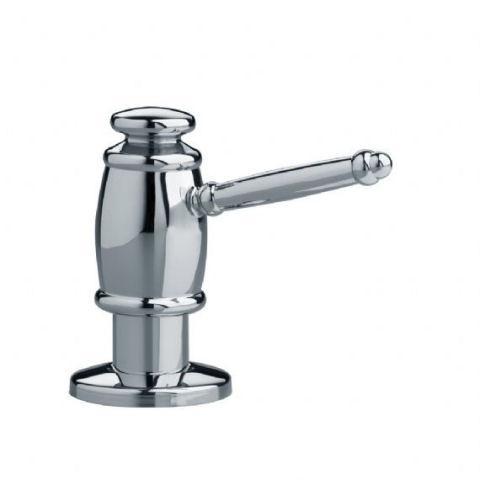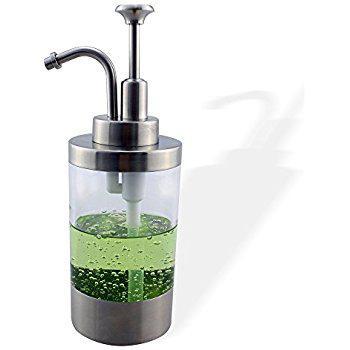The first image is the image on the left, the second image is the image on the right. Evaluate the accuracy of this statement regarding the images: "Each image shows a bank of three lotion dispensers, but only one set has the contents written on each dispenser.". Is it true? Answer yes or no. No. 